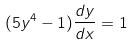Convert formula to latex. <formula><loc_0><loc_0><loc_500><loc_500>( 5 y ^ { 4 } - 1 ) \frac { d y } { d x } = 1</formula> 